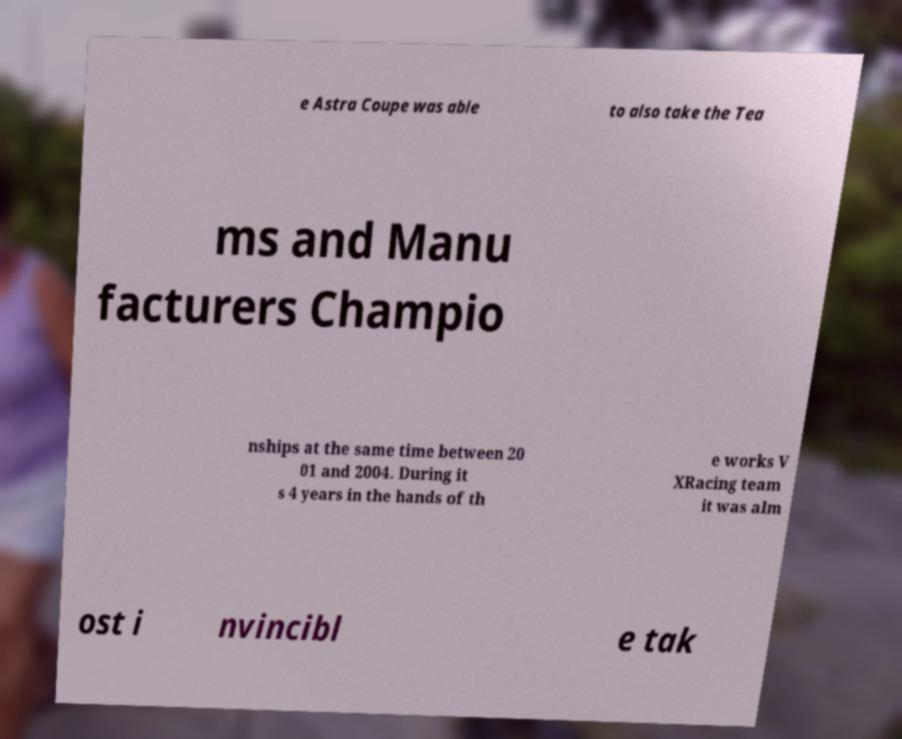Could you extract and type out the text from this image? e Astra Coupe was able to also take the Tea ms and Manu facturers Champio nships at the same time between 20 01 and 2004. During it s 4 years in the hands of th e works V XRacing team it was alm ost i nvincibl e tak 